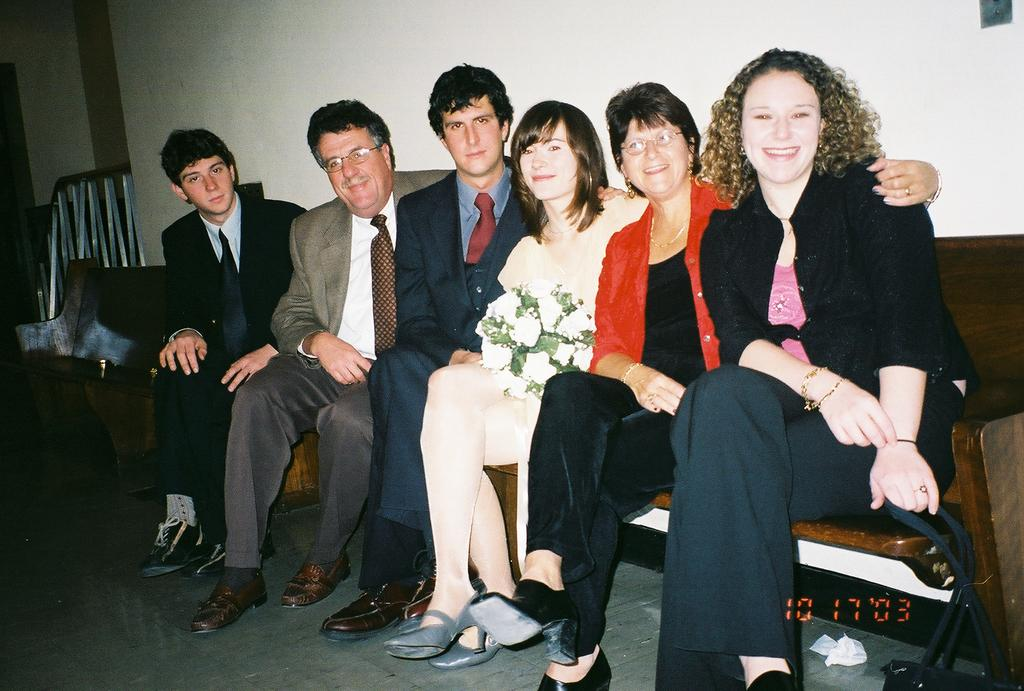What are the people in the image doing? There is a group of people sitting on a bench in the image. What can be found at the bottom of the image? There are numbers at the bottom of the image. What type of fence is visible in the image? There is a metal rod fence in the image. What structure can be seen in the background of the image? There is a wall visible in the image. Are the people in the image being held as slaves? There is no indication in the image that the people are being held as slaves. 